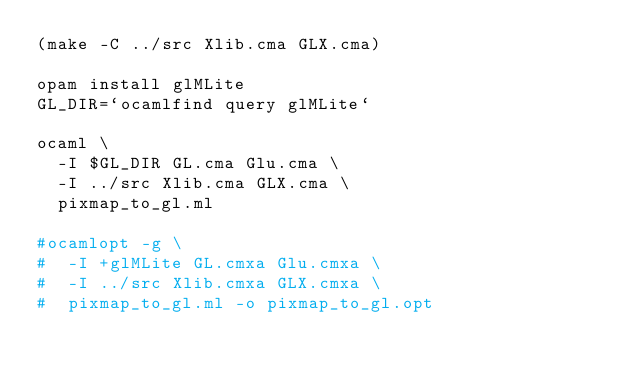Convert code to text. <code><loc_0><loc_0><loc_500><loc_500><_Bash_>(make -C ../src Xlib.cma GLX.cma)

opam install glMLite
GL_DIR=`ocamlfind query glMLite`

ocaml \
  -I $GL_DIR GL.cma Glu.cma \
  -I ../src Xlib.cma GLX.cma \
  pixmap_to_gl.ml

#ocamlopt -g \
#  -I +glMLite GL.cmxa Glu.cmxa \
#  -I ../src Xlib.cmxa GLX.cmxa \
#  pixmap_to_gl.ml -o pixmap_to_gl.opt

</code> 